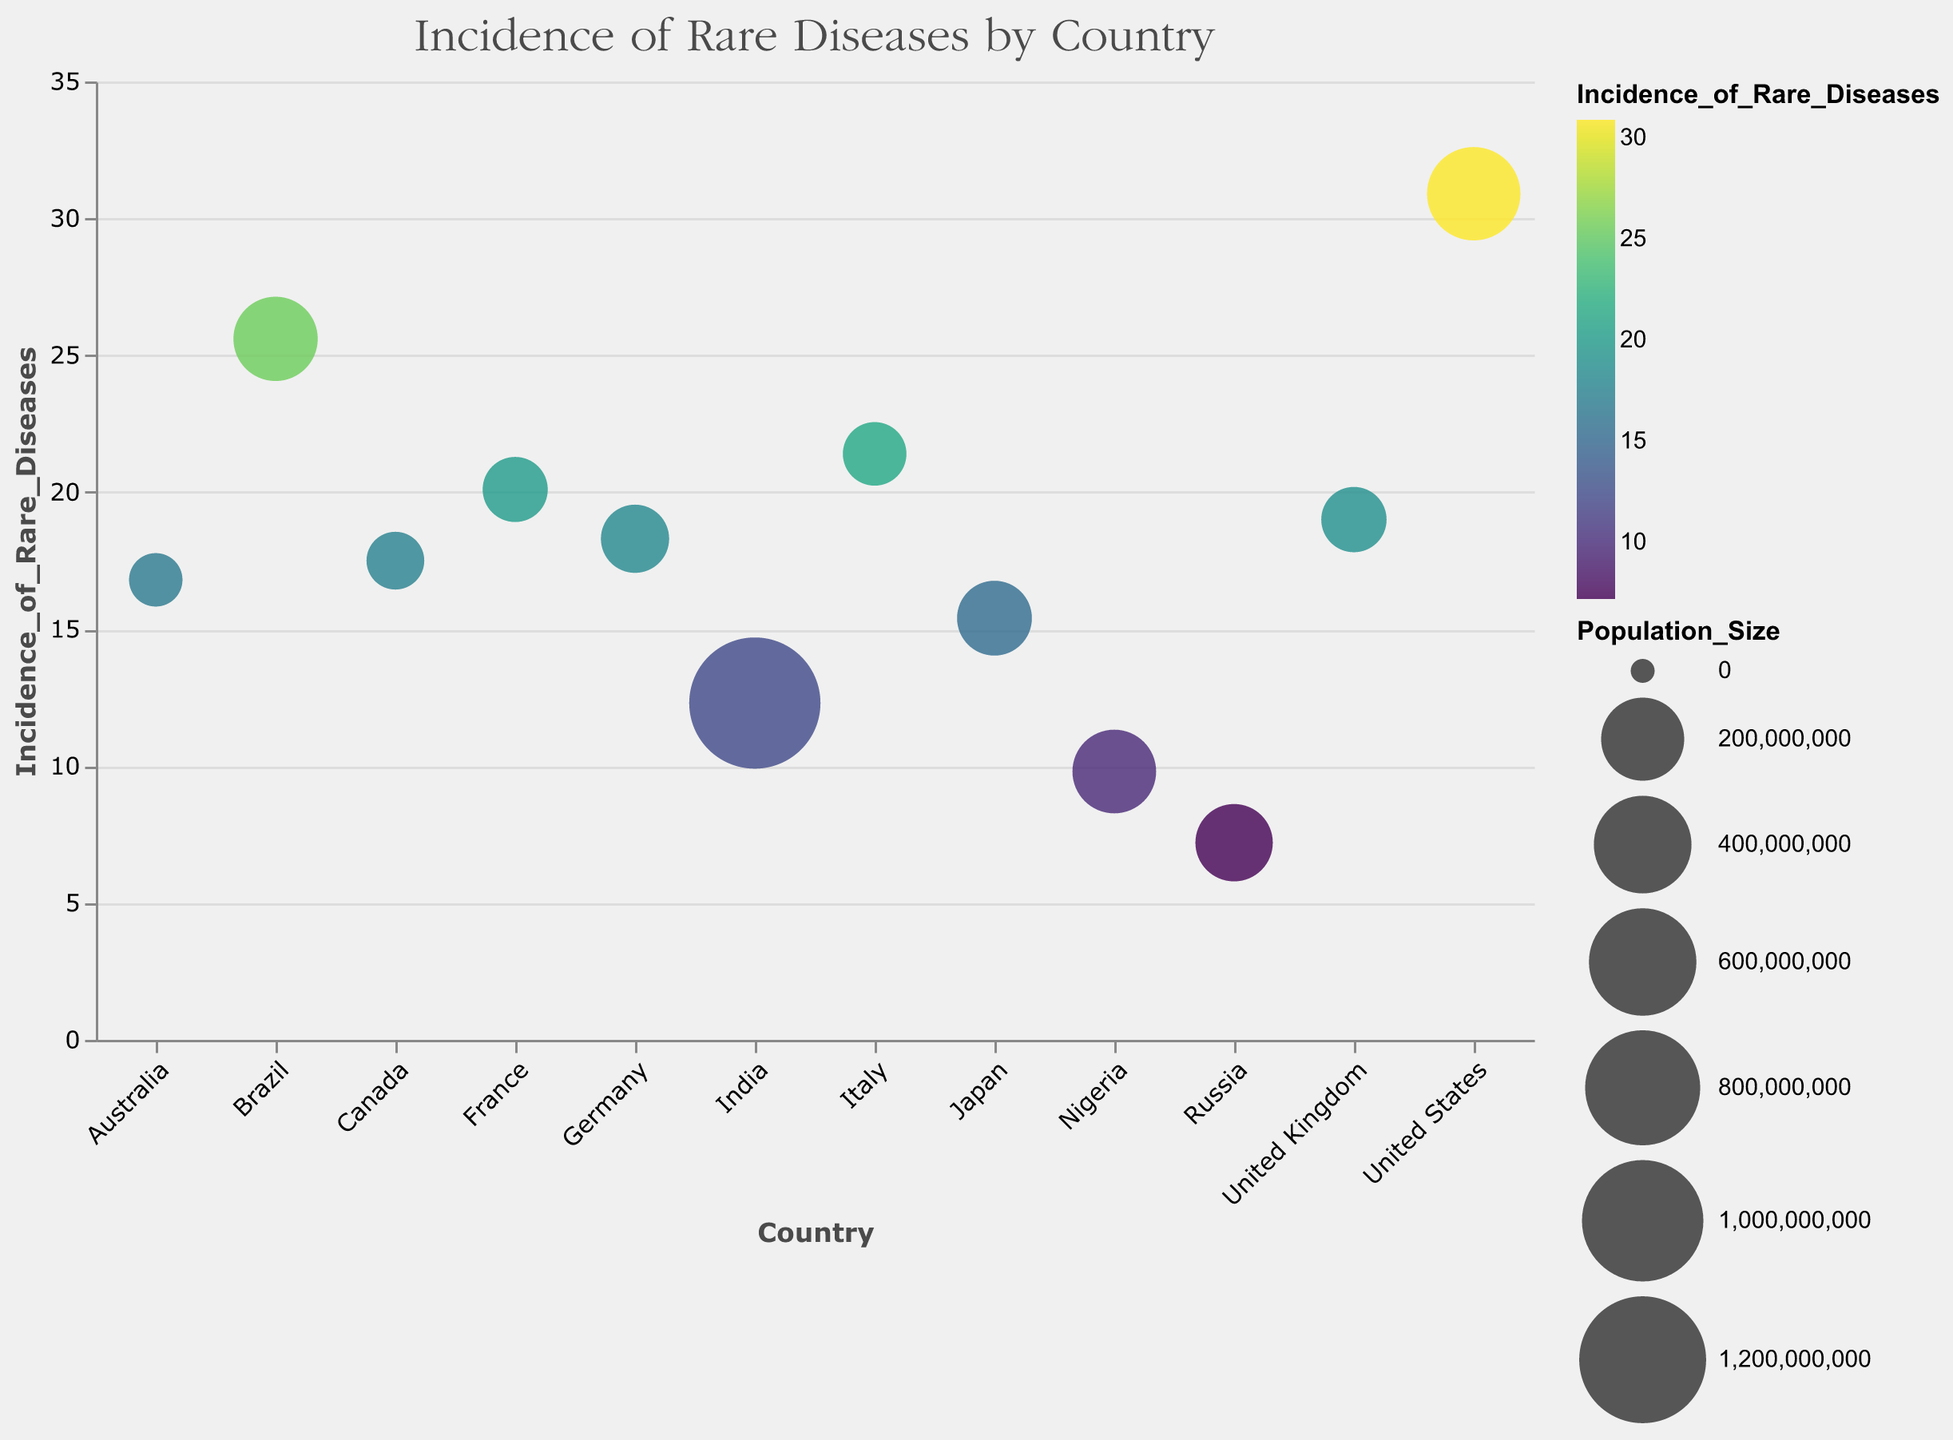What is the title of the figure? The title is usually displayed at the top of the chart. In this figure, it is clearly labeled.
Answer: "Incidence of Rare Diseases by Country" Which country has the highest incidence of rare diseases? To find this, look for the highest bubble along the y-axis. The United States has the highest y-value.
Answer: United States Which country has the lowest incidence of rare diseases? To find this, look for the bubble with the lowest y-value. Russia has the lowest incidence.
Answer: Russia How many countries are displayed in the chart? Count all the bubbles present in the chart, each representing a country. In total, there are 12 bubbles.
Answer: 12 Which country has the largest bubble size in the chart? The bubble size represents the population size. The largest bubble corresponds to India.
Answer: India Compare the incidence of rare diseases between the United Kingdom and Australia. Which country has a higher incidence rate? Compare the y-values of the bubbles for the United Kingdom and Australia. The United Kingdom has a higher incidence value.
Answer: United Kingdom Which two countries have an incidence of rare diseases closest to 20? Look for bubbles with incidence values nearest to 20 on the y-axis. France and Italy have values of 20.1 and 21.4, respectively.
Answer: France and Italy What is the median incidence rate of rare diseases across all countries in the chart? List all incidence rates: 7.2, 9.8, 12.3, 15.4, 16.8, 17.5, 18.3, 19.0, 20.1, 21.4, 25.6, 30.9. To find the median, there are 12 values; the average of the 6th and 7th values after sorting is the median. (16.8 + 17.5) / 2 = 17.15
Answer: 17.15 Which country with a population over 100 million has the lowest incidence of rare diseases? Look for countries with Population_Size > 100,000,000 and then find the lowest incidence rate. Russia, with a population of 146 million and an incidence of 7.2, meets the criteria.
Answer: Russia What is the total population size represented in the chart? Sum up the Population_Size values for all countries. Adding up all the population figures: 3,838,000,000.
Answer: 3,838,000,000 